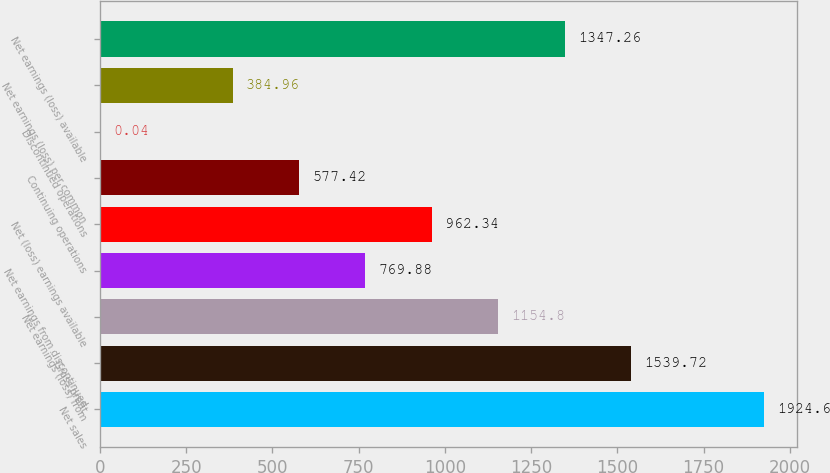Convert chart. <chart><loc_0><loc_0><loc_500><loc_500><bar_chart><fcel>Net sales<fcel>Gross profit<fcel>Net earnings (loss) from<fcel>Net earnings from discontinued<fcel>Net (loss) earnings available<fcel>Continuing operations<fcel>Discontinued operations<fcel>Net earnings (loss) per common<fcel>Net earnings (loss) available<nl><fcel>1924.6<fcel>1539.72<fcel>1154.8<fcel>769.88<fcel>962.34<fcel>577.42<fcel>0.04<fcel>384.96<fcel>1347.26<nl></chart> 